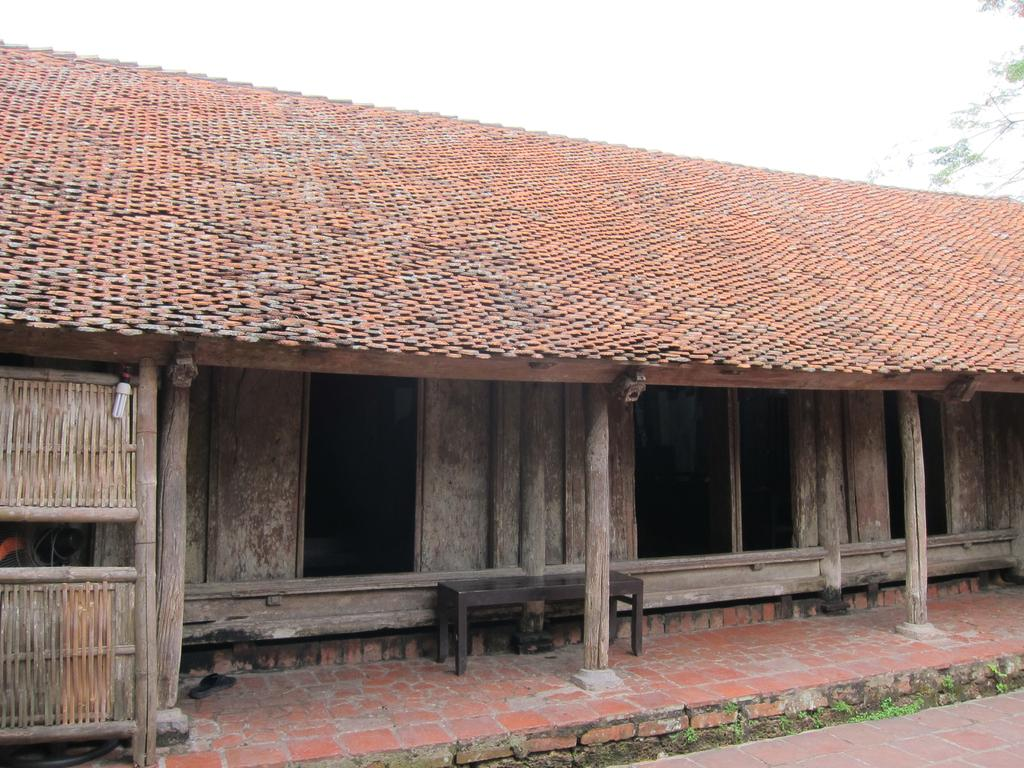What type of house is in the image? There is a wooden house in the image. What can be found inside the house? The presence of a light bulb suggests there may be some form of indoor lighting. What other wooden object is in the image? There is a wooden bench in the image. What material is used for the construction of the house? The house is made of wood, as indicated by the wooden bench and the wooden house itself. What is the structure on top of the house? There is a roof in the image. What type of vegetation is on the right side of the image? There is a tree on the right side of the image. What is visible in the background of the image? The sky is visible in the background of the image. What type of flame can be seen coming from the tree in the image? There is no flame present in the image; it features a wooden house, a light bulb, a wooden bench, bricks, a roof, a tree, and a sky. How does the salt affect the wooden house in the image? There is no salt present in the image, so its effect on the wooden house cannot be determined. 